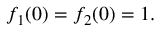Convert formula to latex. <formula><loc_0><loc_0><loc_500><loc_500>f _ { 1 } ( 0 ) = f _ { 2 } ( 0 ) = 1 .</formula> 